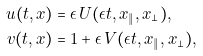<formula> <loc_0><loc_0><loc_500><loc_500>u ( t , x ) & = \epsilon \, U ( \epsilon t , x _ { \| } , x _ { \perp } ) , \\ v ( t , x ) & = 1 + \epsilon \, V ( \epsilon t , x _ { \| } , x _ { \perp } ) ,</formula> 